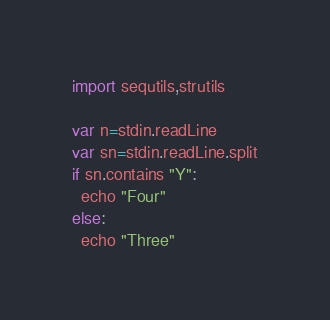<code> <loc_0><loc_0><loc_500><loc_500><_Nim_>import sequtils,strutils

var n=stdin.readLine
var sn=stdin.readLine.split
if sn.contains "Y":
  echo "Four"
else:
  echo "Three"</code> 